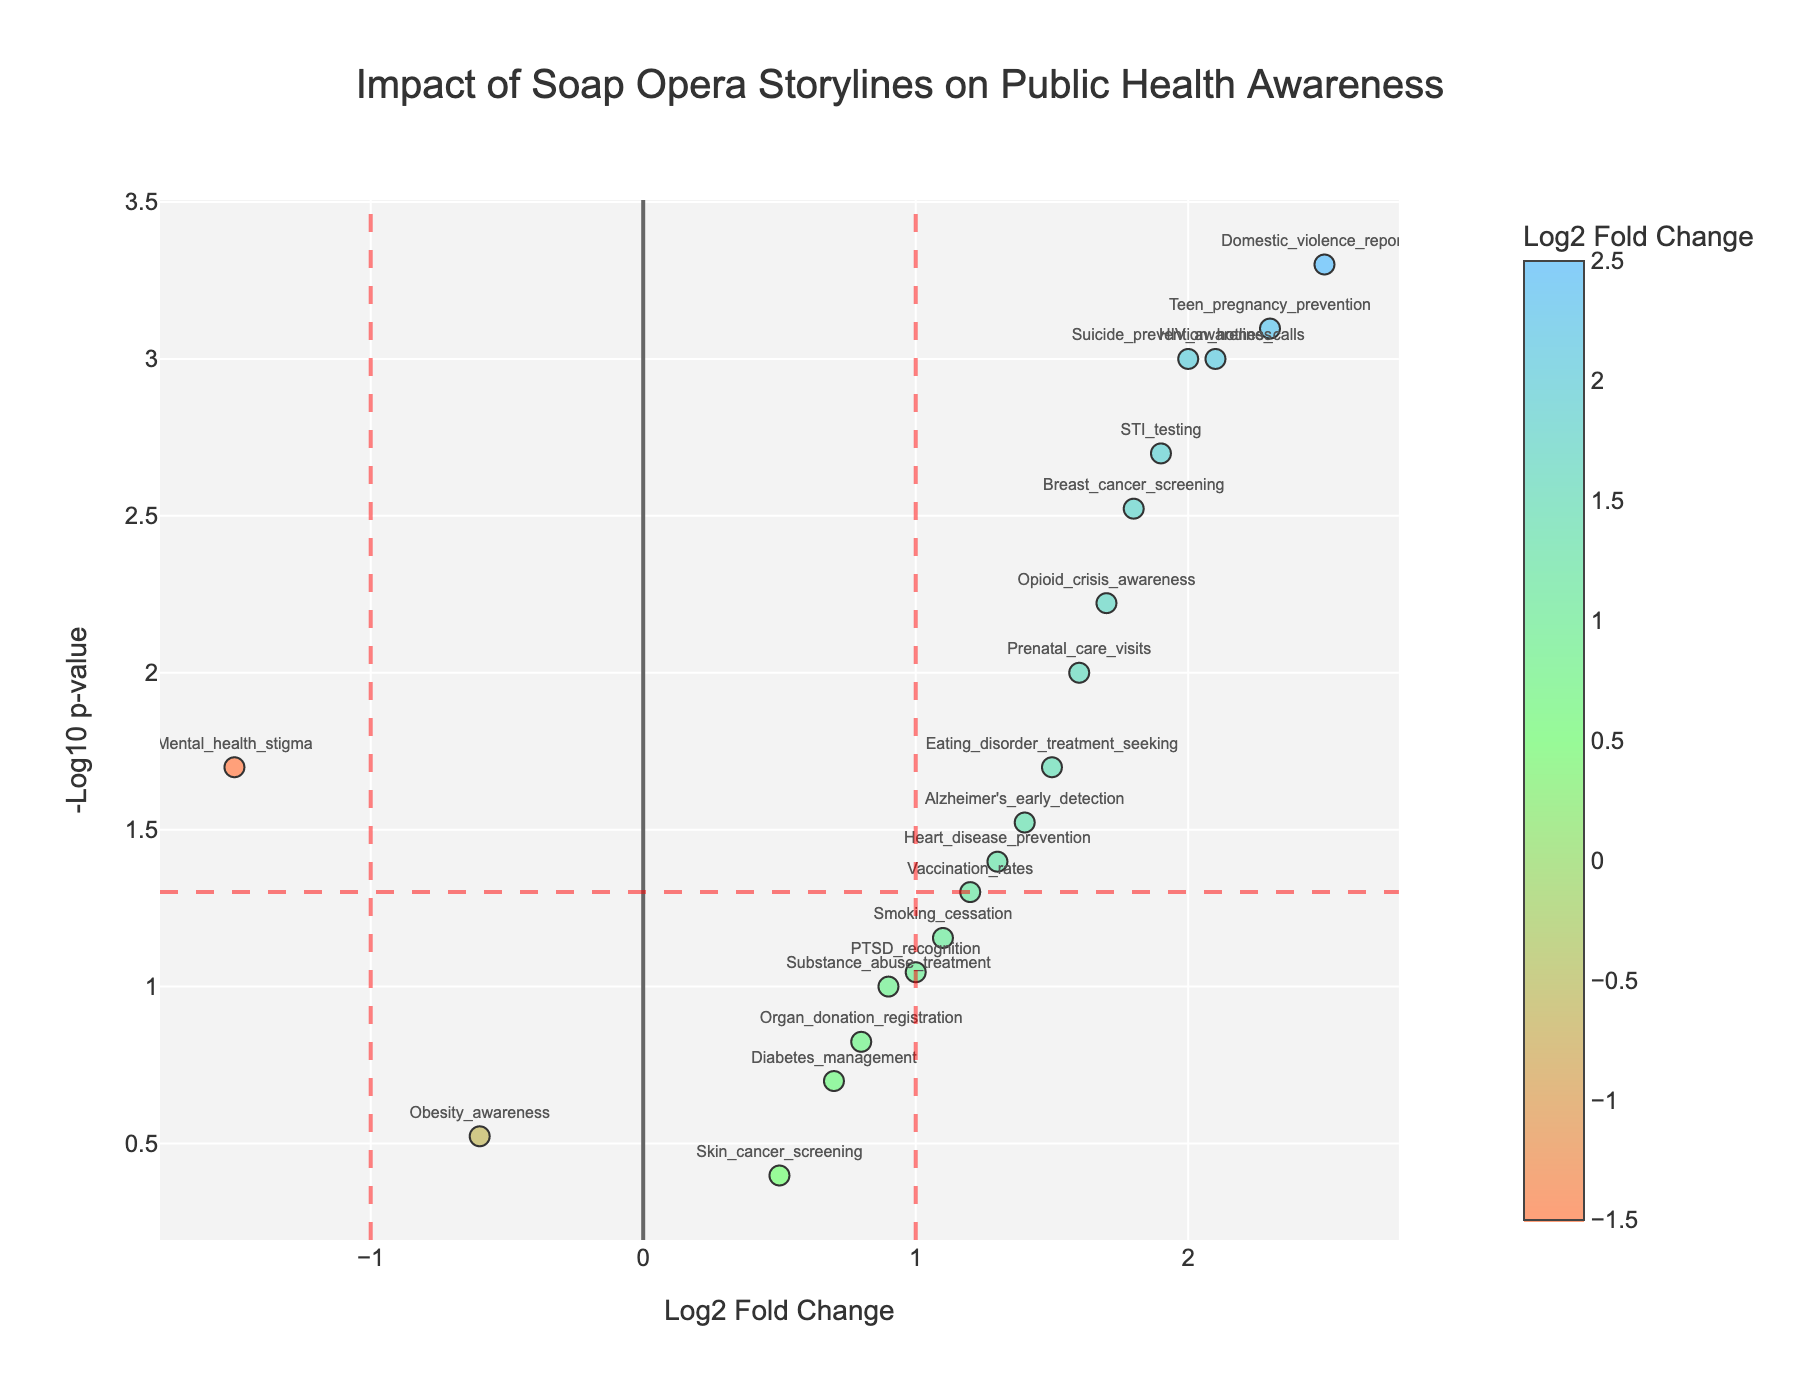What is the title of the figure? The title is located at the top of the figure and it describes the main topic of the plot. It reads: "Impact of Soap Opera Storylines on Public Health Awareness".
Answer: Impact of Soap Opera Storylines on Public Health Awareness Which health-related behavior has the highest log2FoldChange? To determine this, locate the data point farthest to the right on the x-axis (log2FoldChange axis). This point is labeled "Domestic_violence_reporting".
Answer: Domestic_violence_reporting How many behaviors have a p-value less than 0.05? Look for data points that are above the horizontal threshold line at y = -log10(0.05). Count the number of such points. These include "Domestic_violence_reporting", "HIV_awareness", "Breast_cancer_screening", "Mental_health_stigma", "Prenatal_care_visits", "STI_testing", "Teen_pregnancy_prevention", "Opioid_crisis_awareness", "Suicide_prevention_hotline_calls", and "Eating_disorder_treatment_seeking".
Answer: 10 Which behavior shows a negative impact with significant change? Look for data points on the left side of the vertical line at x = -1 and above the horizontal line at y = -log10(0.05). This point is labeled "Mental_health_stigma".
Answer: Mental_health_stigma What is the log2FoldChange for "Suicide_prevention_hotline_calls" and its p-value? Locate the data point labeled "Suicide_prevention_hotline_calls" in the plot. The hover text for this point provides the log2FoldChange and p-value, which are 2.0 and 0.001, respectively.
Answer: 2.0, 0.001 